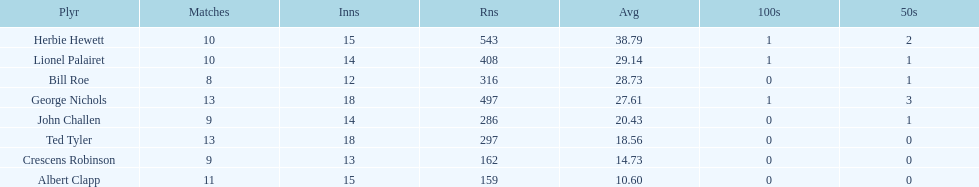Which player had the least amount of runs? Albert Clapp. 